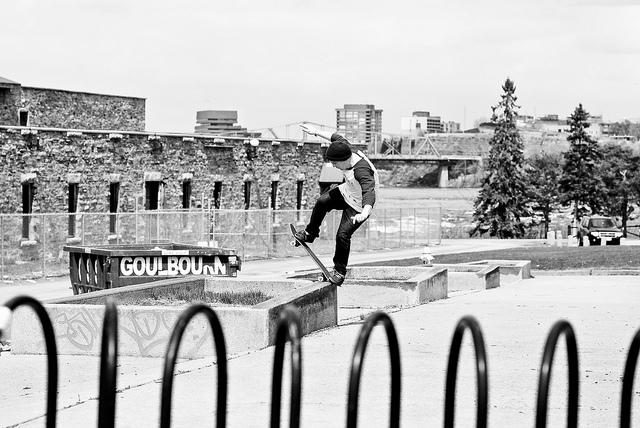What is the purpose of the hoops pictured in the foreground?
Be succinct. Bike rack. What separates the area where the man is skating and the building to the left?
Concise answer only. Fence. Is there graffiti in this photo?
Concise answer only. Yes. 